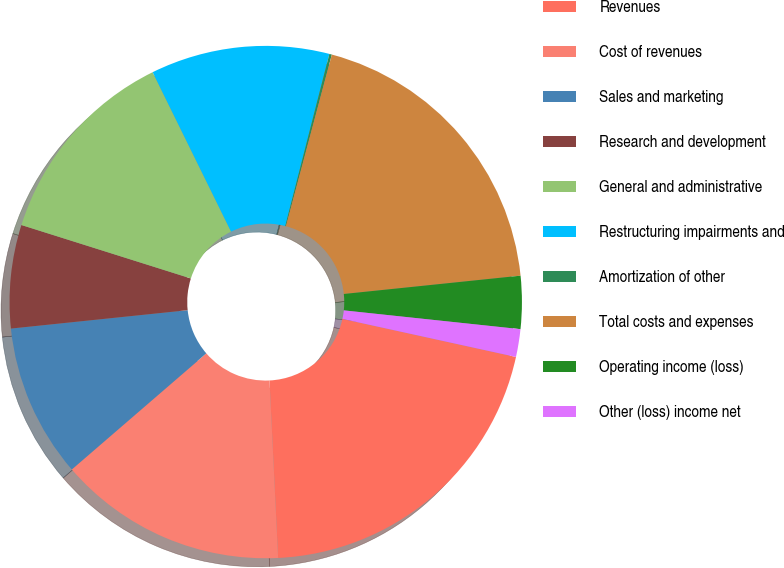Convert chart to OTSL. <chart><loc_0><loc_0><loc_500><loc_500><pie_chart><fcel>Revenues<fcel>Cost of revenues<fcel>Sales and marketing<fcel>Research and development<fcel>General and administrative<fcel>Restructuring impairments and<fcel>Amortization of other<fcel>Total costs and expenses<fcel>Operating income (loss)<fcel>Other (loss) income net<nl><fcel>20.79%<fcel>14.44%<fcel>9.68%<fcel>6.51%<fcel>12.86%<fcel>11.27%<fcel>0.16%<fcel>19.2%<fcel>3.33%<fcel>1.75%<nl></chart> 